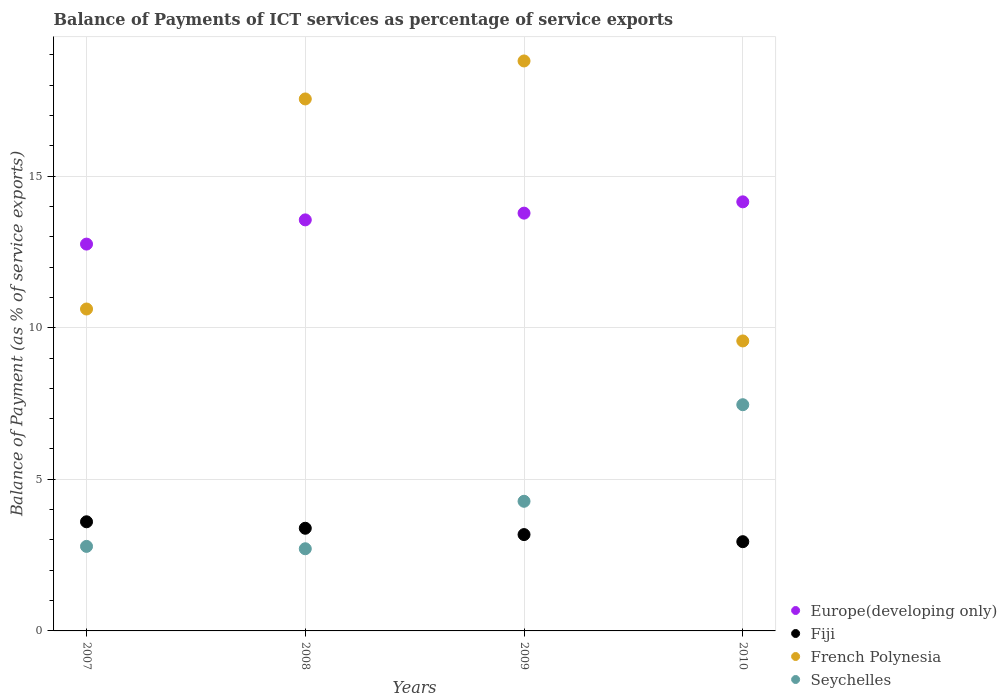What is the balance of payments of ICT services in Europe(developing only) in 2010?
Your answer should be very brief. 14.15. Across all years, what is the maximum balance of payments of ICT services in French Polynesia?
Your response must be concise. 18.8. Across all years, what is the minimum balance of payments of ICT services in French Polynesia?
Make the answer very short. 9.56. In which year was the balance of payments of ICT services in Europe(developing only) maximum?
Ensure brevity in your answer.  2010. In which year was the balance of payments of ICT services in French Polynesia minimum?
Provide a short and direct response. 2010. What is the total balance of payments of ICT services in French Polynesia in the graph?
Offer a very short reply. 56.52. What is the difference between the balance of payments of ICT services in French Polynesia in 2008 and that in 2010?
Provide a short and direct response. 7.98. What is the difference between the balance of payments of ICT services in Europe(developing only) in 2010 and the balance of payments of ICT services in Fiji in 2007?
Your answer should be very brief. 10.55. What is the average balance of payments of ICT services in Europe(developing only) per year?
Your response must be concise. 13.56. In the year 2009, what is the difference between the balance of payments of ICT services in Seychelles and balance of payments of ICT services in Fiji?
Keep it short and to the point. 1.1. What is the ratio of the balance of payments of ICT services in Seychelles in 2007 to that in 2010?
Give a very brief answer. 0.37. Is the difference between the balance of payments of ICT services in Seychelles in 2008 and 2009 greater than the difference between the balance of payments of ICT services in Fiji in 2008 and 2009?
Ensure brevity in your answer.  No. What is the difference between the highest and the second highest balance of payments of ICT services in Seychelles?
Provide a short and direct response. 3.18. What is the difference between the highest and the lowest balance of payments of ICT services in Seychelles?
Make the answer very short. 4.75. Is it the case that in every year, the sum of the balance of payments of ICT services in French Polynesia and balance of payments of ICT services in Europe(developing only)  is greater than the sum of balance of payments of ICT services in Seychelles and balance of payments of ICT services in Fiji?
Offer a very short reply. Yes. Is the balance of payments of ICT services in Seychelles strictly greater than the balance of payments of ICT services in Fiji over the years?
Your response must be concise. No. How many years are there in the graph?
Provide a short and direct response. 4. Are the values on the major ticks of Y-axis written in scientific E-notation?
Give a very brief answer. No. Does the graph contain grids?
Keep it short and to the point. Yes. Where does the legend appear in the graph?
Offer a very short reply. Bottom right. How are the legend labels stacked?
Ensure brevity in your answer.  Vertical. What is the title of the graph?
Give a very brief answer. Balance of Payments of ICT services as percentage of service exports. What is the label or title of the Y-axis?
Provide a short and direct response. Balance of Payment (as % of service exports). What is the Balance of Payment (as % of service exports) of Europe(developing only) in 2007?
Give a very brief answer. 12.76. What is the Balance of Payment (as % of service exports) in Fiji in 2007?
Your answer should be compact. 3.6. What is the Balance of Payment (as % of service exports) in French Polynesia in 2007?
Your answer should be compact. 10.62. What is the Balance of Payment (as % of service exports) of Seychelles in 2007?
Your answer should be compact. 2.79. What is the Balance of Payment (as % of service exports) of Europe(developing only) in 2008?
Your answer should be compact. 13.56. What is the Balance of Payment (as % of service exports) of Fiji in 2008?
Give a very brief answer. 3.39. What is the Balance of Payment (as % of service exports) of French Polynesia in 2008?
Make the answer very short. 17.54. What is the Balance of Payment (as % of service exports) of Seychelles in 2008?
Make the answer very short. 2.71. What is the Balance of Payment (as % of service exports) of Europe(developing only) in 2009?
Your answer should be very brief. 13.78. What is the Balance of Payment (as % of service exports) of Fiji in 2009?
Provide a succinct answer. 3.18. What is the Balance of Payment (as % of service exports) in French Polynesia in 2009?
Make the answer very short. 18.8. What is the Balance of Payment (as % of service exports) of Seychelles in 2009?
Offer a terse response. 4.28. What is the Balance of Payment (as % of service exports) of Europe(developing only) in 2010?
Your answer should be very brief. 14.15. What is the Balance of Payment (as % of service exports) in Fiji in 2010?
Make the answer very short. 2.94. What is the Balance of Payment (as % of service exports) in French Polynesia in 2010?
Keep it short and to the point. 9.56. What is the Balance of Payment (as % of service exports) of Seychelles in 2010?
Offer a terse response. 7.46. Across all years, what is the maximum Balance of Payment (as % of service exports) of Europe(developing only)?
Offer a very short reply. 14.15. Across all years, what is the maximum Balance of Payment (as % of service exports) of Fiji?
Your response must be concise. 3.6. Across all years, what is the maximum Balance of Payment (as % of service exports) in French Polynesia?
Make the answer very short. 18.8. Across all years, what is the maximum Balance of Payment (as % of service exports) of Seychelles?
Your response must be concise. 7.46. Across all years, what is the minimum Balance of Payment (as % of service exports) of Europe(developing only)?
Offer a terse response. 12.76. Across all years, what is the minimum Balance of Payment (as % of service exports) of Fiji?
Your answer should be very brief. 2.94. Across all years, what is the minimum Balance of Payment (as % of service exports) of French Polynesia?
Your answer should be very brief. 9.56. Across all years, what is the minimum Balance of Payment (as % of service exports) of Seychelles?
Keep it short and to the point. 2.71. What is the total Balance of Payment (as % of service exports) of Europe(developing only) in the graph?
Keep it short and to the point. 54.24. What is the total Balance of Payment (as % of service exports) in Fiji in the graph?
Offer a terse response. 13.1. What is the total Balance of Payment (as % of service exports) of French Polynesia in the graph?
Make the answer very short. 56.52. What is the total Balance of Payment (as % of service exports) in Seychelles in the graph?
Your response must be concise. 17.23. What is the difference between the Balance of Payment (as % of service exports) of Europe(developing only) in 2007 and that in 2008?
Keep it short and to the point. -0.8. What is the difference between the Balance of Payment (as % of service exports) in Fiji in 2007 and that in 2008?
Give a very brief answer. 0.21. What is the difference between the Balance of Payment (as % of service exports) in French Polynesia in 2007 and that in 2008?
Provide a short and direct response. -6.93. What is the difference between the Balance of Payment (as % of service exports) in Seychelles in 2007 and that in 2008?
Provide a short and direct response. 0.08. What is the difference between the Balance of Payment (as % of service exports) in Europe(developing only) in 2007 and that in 2009?
Your answer should be compact. -1.02. What is the difference between the Balance of Payment (as % of service exports) in Fiji in 2007 and that in 2009?
Offer a very short reply. 0.42. What is the difference between the Balance of Payment (as % of service exports) of French Polynesia in 2007 and that in 2009?
Your response must be concise. -8.18. What is the difference between the Balance of Payment (as % of service exports) in Seychelles in 2007 and that in 2009?
Your answer should be very brief. -1.49. What is the difference between the Balance of Payment (as % of service exports) in Europe(developing only) in 2007 and that in 2010?
Keep it short and to the point. -1.39. What is the difference between the Balance of Payment (as % of service exports) in Fiji in 2007 and that in 2010?
Keep it short and to the point. 0.66. What is the difference between the Balance of Payment (as % of service exports) of French Polynesia in 2007 and that in 2010?
Provide a short and direct response. 1.05. What is the difference between the Balance of Payment (as % of service exports) in Seychelles in 2007 and that in 2010?
Ensure brevity in your answer.  -4.67. What is the difference between the Balance of Payment (as % of service exports) in Europe(developing only) in 2008 and that in 2009?
Ensure brevity in your answer.  -0.22. What is the difference between the Balance of Payment (as % of service exports) in Fiji in 2008 and that in 2009?
Make the answer very short. 0.21. What is the difference between the Balance of Payment (as % of service exports) of French Polynesia in 2008 and that in 2009?
Provide a succinct answer. -1.25. What is the difference between the Balance of Payment (as % of service exports) of Seychelles in 2008 and that in 2009?
Your response must be concise. -1.57. What is the difference between the Balance of Payment (as % of service exports) in Europe(developing only) in 2008 and that in 2010?
Your response must be concise. -0.59. What is the difference between the Balance of Payment (as % of service exports) in Fiji in 2008 and that in 2010?
Give a very brief answer. 0.44. What is the difference between the Balance of Payment (as % of service exports) in French Polynesia in 2008 and that in 2010?
Make the answer very short. 7.98. What is the difference between the Balance of Payment (as % of service exports) in Seychelles in 2008 and that in 2010?
Provide a succinct answer. -4.75. What is the difference between the Balance of Payment (as % of service exports) of Europe(developing only) in 2009 and that in 2010?
Make the answer very short. -0.37. What is the difference between the Balance of Payment (as % of service exports) in Fiji in 2009 and that in 2010?
Provide a short and direct response. 0.23. What is the difference between the Balance of Payment (as % of service exports) of French Polynesia in 2009 and that in 2010?
Offer a terse response. 9.23. What is the difference between the Balance of Payment (as % of service exports) of Seychelles in 2009 and that in 2010?
Give a very brief answer. -3.18. What is the difference between the Balance of Payment (as % of service exports) of Europe(developing only) in 2007 and the Balance of Payment (as % of service exports) of Fiji in 2008?
Provide a succinct answer. 9.37. What is the difference between the Balance of Payment (as % of service exports) in Europe(developing only) in 2007 and the Balance of Payment (as % of service exports) in French Polynesia in 2008?
Keep it short and to the point. -4.79. What is the difference between the Balance of Payment (as % of service exports) of Europe(developing only) in 2007 and the Balance of Payment (as % of service exports) of Seychelles in 2008?
Give a very brief answer. 10.05. What is the difference between the Balance of Payment (as % of service exports) of Fiji in 2007 and the Balance of Payment (as % of service exports) of French Polynesia in 2008?
Provide a succinct answer. -13.94. What is the difference between the Balance of Payment (as % of service exports) of Fiji in 2007 and the Balance of Payment (as % of service exports) of Seychelles in 2008?
Your answer should be very brief. 0.89. What is the difference between the Balance of Payment (as % of service exports) in French Polynesia in 2007 and the Balance of Payment (as % of service exports) in Seychelles in 2008?
Your answer should be very brief. 7.91. What is the difference between the Balance of Payment (as % of service exports) in Europe(developing only) in 2007 and the Balance of Payment (as % of service exports) in Fiji in 2009?
Your response must be concise. 9.58. What is the difference between the Balance of Payment (as % of service exports) of Europe(developing only) in 2007 and the Balance of Payment (as % of service exports) of French Polynesia in 2009?
Give a very brief answer. -6.04. What is the difference between the Balance of Payment (as % of service exports) of Europe(developing only) in 2007 and the Balance of Payment (as % of service exports) of Seychelles in 2009?
Provide a succinct answer. 8.48. What is the difference between the Balance of Payment (as % of service exports) of Fiji in 2007 and the Balance of Payment (as % of service exports) of French Polynesia in 2009?
Give a very brief answer. -15.2. What is the difference between the Balance of Payment (as % of service exports) of Fiji in 2007 and the Balance of Payment (as % of service exports) of Seychelles in 2009?
Keep it short and to the point. -0.68. What is the difference between the Balance of Payment (as % of service exports) of French Polynesia in 2007 and the Balance of Payment (as % of service exports) of Seychelles in 2009?
Offer a very short reply. 6.34. What is the difference between the Balance of Payment (as % of service exports) of Europe(developing only) in 2007 and the Balance of Payment (as % of service exports) of Fiji in 2010?
Make the answer very short. 9.81. What is the difference between the Balance of Payment (as % of service exports) of Europe(developing only) in 2007 and the Balance of Payment (as % of service exports) of French Polynesia in 2010?
Ensure brevity in your answer.  3.19. What is the difference between the Balance of Payment (as % of service exports) in Europe(developing only) in 2007 and the Balance of Payment (as % of service exports) in Seychelles in 2010?
Keep it short and to the point. 5.3. What is the difference between the Balance of Payment (as % of service exports) of Fiji in 2007 and the Balance of Payment (as % of service exports) of French Polynesia in 2010?
Provide a succinct answer. -5.96. What is the difference between the Balance of Payment (as % of service exports) of Fiji in 2007 and the Balance of Payment (as % of service exports) of Seychelles in 2010?
Provide a short and direct response. -3.86. What is the difference between the Balance of Payment (as % of service exports) in French Polynesia in 2007 and the Balance of Payment (as % of service exports) in Seychelles in 2010?
Provide a succinct answer. 3.16. What is the difference between the Balance of Payment (as % of service exports) in Europe(developing only) in 2008 and the Balance of Payment (as % of service exports) in Fiji in 2009?
Ensure brevity in your answer.  10.38. What is the difference between the Balance of Payment (as % of service exports) in Europe(developing only) in 2008 and the Balance of Payment (as % of service exports) in French Polynesia in 2009?
Ensure brevity in your answer.  -5.24. What is the difference between the Balance of Payment (as % of service exports) in Europe(developing only) in 2008 and the Balance of Payment (as % of service exports) in Seychelles in 2009?
Ensure brevity in your answer.  9.28. What is the difference between the Balance of Payment (as % of service exports) in Fiji in 2008 and the Balance of Payment (as % of service exports) in French Polynesia in 2009?
Offer a terse response. -15.41. What is the difference between the Balance of Payment (as % of service exports) in Fiji in 2008 and the Balance of Payment (as % of service exports) in Seychelles in 2009?
Make the answer very short. -0.89. What is the difference between the Balance of Payment (as % of service exports) of French Polynesia in 2008 and the Balance of Payment (as % of service exports) of Seychelles in 2009?
Offer a very short reply. 13.27. What is the difference between the Balance of Payment (as % of service exports) of Europe(developing only) in 2008 and the Balance of Payment (as % of service exports) of Fiji in 2010?
Offer a terse response. 10.61. What is the difference between the Balance of Payment (as % of service exports) of Europe(developing only) in 2008 and the Balance of Payment (as % of service exports) of French Polynesia in 2010?
Ensure brevity in your answer.  3.99. What is the difference between the Balance of Payment (as % of service exports) in Europe(developing only) in 2008 and the Balance of Payment (as % of service exports) in Seychelles in 2010?
Keep it short and to the point. 6.1. What is the difference between the Balance of Payment (as % of service exports) of Fiji in 2008 and the Balance of Payment (as % of service exports) of French Polynesia in 2010?
Provide a short and direct response. -6.18. What is the difference between the Balance of Payment (as % of service exports) in Fiji in 2008 and the Balance of Payment (as % of service exports) in Seychelles in 2010?
Provide a short and direct response. -4.07. What is the difference between the Balance of Payment (as % of service exports) in French Polynesia in 2008 and the Balance of Payment (as % of service exports) in Seychelles in 2010?
Your answer should be compact. 10.08. What is the difference between the Balance of Payment (as % of service exports) in Europe(developing only) in 2009 and the Balance of Payment (as % of service exports) in Fiji in 2010?
Offer a very short reply. 10.83. What is the difference between the Balance of Payment (as % of service exports) in Europe(developing only) in 2009 and the Balance of Payment (as % of service exports) in French Polynesia in 2010?
Provide a short and direct response. 4.21. What is the difference between the Balance of Payment (as % of service exports) in Europe(developing only) in 2009 and the Balance of Payment (as % of service exports) in Seychelles in 2010?
Keep it short and to the point. 6.32. What is the difference between the Balance of Payment (as % of service exports) in Fiji in 2009 and the Balance of Payment (as % of service exports) in French Polynesia in 2010?
Keep it short and to the point. -6.39. What is the difference between the Balance of Payment (as % of service exports) in Fiji in 2009 and the Balance of Payment (as % of service exports) in Seychelles in 2010?
Give a very brief answer. -4.28. What is the difference between the Balance of Payment (as % of service exports) of French Polynesia in 2009 and the Balance of Payment (as % of service exports) of Seychelles in 2010?
Make the answer very short. 11.34. What is the average Balance of Payment (as % of service exports) in Europe(developing only) per year?
Keep it short and to the point. 13.56. What is the average Balance of Payment (as % of service exports) of Fiji per year?
Your response must be concise. 3.28. What is the average Balance of Payment (as % of service exports) of French Polynesia per year?
Ensure brevity in your answer.  14.13. What is the average Balance of Payment (as % of service exports) in Seychelles per year?
Make the answer very short. 4.31. In the year 2007, what is the difference between the Balance of Payment (as % of service exports) in Europe(developing only) and Balance of Payment (as % of service exports) in Fiji?
Ensure brevity in your answer.  9.16. In the year 2007, what is the difference between the Balance of Payment (as % of service exports) of Europe(developing only) and Balance of Payment (as % of service exports) of French Polynesia?
Offer a terse response. 2.14. In the year 2007, what is the difference between the Balance of Payment (as % of service exports) in Europe(developing only) and Balance of Payment (as % of service exports) in Seychelles?
Provide a short and direct response. 9.97. In the year 2007, what is the difference between the Balance of Payment (as % of service exports) of Fiji and Balance of Payment (as % of service exports) of French Polynesia?
Provide a succinct answer. -7.02. In the year 2007, what is the difference between the Balance of Payment (as % of service exports) in Fiji and Balance of Payment (as % of service exports) in Seychelles?
Offer a terse response. 0.81. In the year 2007, what is the difference between the Balance of Payment (as % of service exports) of French Polynesia and Balance of Payment (as % of service exports) of Seychelles?
Your answer should be compact. 7.83. In the year 2008, what is the difference between the Balance of Payment (as % of service exports) of Europe(developing only) and Balance of Payment (as % of service exports) of Fiji?
Provide a short and direct response. 10.17. In the year 2008, what is the difference between the Balance of Payment (as % of service exports) in Europe(developing only) and Balance of Payment (as % of service exports) in French Polynesia?
Your answer should be compact. -3.99. In the year 2008, what is the difference between the Balance of Payment (as % of service exports) in Europe(developing only) and Balance of Payment (as % of service exports) in Seychelles?
Offer a very short reply. 10.85. In the year 2008, what is the difference between the Balance of Payment (as % of service exports) in Fiji and Balance of Payment (as % of service exports) in French Polynesia?
Keep it short and to the point. -14.16. In the year 2008, what is the difference between the Balance of Payment (as % of service exports) in Fiji and Balance of Payment (as % of service exports) in Seychelles?
Ensure brevity in your answer.  0.68. In the year 2008, what is the difference between the Balance of Payment (as % of service exports) in French Polynesia and Balance of Payment (as % of service exports) in Seychelles?
Your answer should be very brief. 14.83. In the year 2009, what is the difference between the Balance of Payment (as % of service exports) of Europe(developing only) and Balance of Payment (as % of service exports) of Fiji?
Your answer should be very brief. 10.6. In the year 2009, what is the difference between the Balance of Payment (as % of service exports) in Europe(developing only) and Balance of Payment (as % of service exports) in French Polynesia?
Your answer should be very brief. -5.02. In the year 2009, what is the difference between the Balance of Payment (as % of service exports) of Europe(developing only) and Balance of Payment (as % of service exports) of Seychelles?
Ensure brevity in your answer.  9.5. In the year 2009, what is the difference between the Balance of Payment (as % of service exports) in Fiji and Balance of Payment (as % of service exports) in French Polynesia?
Offer a very short reply. -15.62. In the year 2009, what is the difference between the Balance of Payment (as % of service exports) in Fiji and Balance of Payment (as % of service exports) in Seychelles?
Keep it short and to the point. -1.1. In the year 2009, what is the difference between the Balance of Payment (as % of service exports) of French Polynesia and Balance of Payment (as % of service exports) of Seychelles?
Provide a succinct answer. 14.52. In the year 2010, what is the difference between the Balance of Payment (as % of service exports) of Europe(developing only) and Balance of Payment (as % of service exports) of Fiji?
Provide a short and direct response. 11.21. In the year 2010, what is the difference between the Balance of Payment (as % of service exports) in Europe(developing only) and Balance of Payment (as % of service exports) in French Polynesia?
Make the answer very short. 4.59. In the year 2010, what is the difference between the Balance of Payment (as % of service exports) in Europe(developing only) and Balance of Payment (as % of service exports) in Seychelles?
Offer a very short reply. 6.69. In the year 2010, what is the difference between the Balance of Payment (as % of service exports) of Fiji and Balance of Payment (as % of service exports) of French Polynesia?
Your answer should be compact. -6.62. In the year 2010, what is the difference between the Balance of Payment (as % of service exports) in Fiji and Balance of Payment (as % of service exports) in Seychelles?
Offer a terse response. -4.52. In the year 2010, what is the difference between the Balance of Payment (as % of service exports) in French Polynesia and Balance of Payment (as % of service exports) in Seychelles?
Your answer should be compact. 2.1. What is the ratio of the Balance of Payment (as % of service exports) of Europe(developing only) in 2007 to that in 2008?
Ensure brevity in your answer.  0.94. What is the ratio of the Balance of Payment (as % of service exports) in Fiji in 2007 to that in 2008?
Offer a very short reply. 1.06. What is the ratio of the Balance of Payment (as % of service exports) of French Polynesia in 2007 to that in 2008?
Your answer should be very brief. 0.61. What is the ratio of the Balance of Payment (as % of service exports) in Seychelles in 2007 to that in 2008?
Keep it short and to the point. 1.03. What is the ratio of the Balance of Payment (as % of service exports) in Europe(developing only) in 2007 to that in 2009?
Give a very brief answer. 0.93. What is the ratio of the Balance of Payment (as % of service exports) of Fiji in 2007 to that in 2009?
Keep it short and to the point. 1.13. What is the ratio of the Balance of Payment (as % of service exports) of French Polynesia in 2007 to that in 2009?
Your answer should be compact. 0.56. What is the ratio of the Balance of Payment (as % of service exports) of Seychelles in 2007 to that in 2009?
Your response must be concise. 0.65. What is the ratio of the Balance of Payment (as % of service exports) of Europe(developing only) in 2007 to that in 2010?
Give a very brief answer. 0.9. What is the ratio of the Balance of Payment (as % of service exports) in Fiji in 2007 to that in 2010?
Offer a very short reply. 1.22. What is the ratio of the Balance of Payment (as % of service exports) of French Polynesia in 2007 to that in 2010?
Offer a very short reply. 1.11. What is the ratio of the Balance of Payment (as % of service exports) of Seychelles in 2007 to that in 2010?
Provide a succinct answer. 0.37. What is the ratio of the Balance of Payment (as % of service exports) of Europe(developing only) in 2008 to that in 2009?
Make the answer very short. 0.98. What is the ratio of the Balance of Payment (as % of service exports) in Fiji in 2008 to that in 2009?
Give a very brief answer. 1.07. What is the ratio of the Balance of Payment (as % of service exports) of French Polynesia in 2008 to that in 2009?
Your answer should be compact. 0.93. What is the ratio of the Balance of Payment (as % of service exports) of Seychelles in 2008 to that in 2009?
Make the answer very short. 0.63. What is the ratio of the Balance of Payment (as % of service exports) of Europe(developing only) in 2008 to that in 2010?
Your response must be concise. 0.96. What is the ratio of the Balance of Payment (as % of service exports) of Fiji in 2008 to that in 2010?
Your response must be concise. 1.15. What is the ratio of the Balance of Payment (as % of service exports) in French Polynesia in 2008 to that in 2010?
Provide a short and direct response. 1.83. What is the ratio of the Balance of Payment (as % of service exports) of Seychelles in 2008 to that in 2010?
Keep it short and to the point. 0.36. What is the ratio of the Balance of Payment (as % of service exports) in Europe(developing only) in 2009 to that in 2010?
Your answer should be compact. 0.97. What is the ratio of the Balance of Payment (as % of service exports) in Fiji in 2009 to that in 2010?
Make the answer very short. 1.08. What is the ratio of the Balance of Payment (as % of service exports) of French Polynesia in 2009 to that in 2010?
Ensure brevity in your answer.  1.97. What is the ratio of the Balance of Payment (as % of service exports) in Seychelles in 2009 to that in 2010?
Make the answer very short. 0.57. What is the difference between the highest and the second highest Balance of Payment (as % of service exports) in Europe(developing only)?
Your answer should be very brief. 0.37. What is the difference between the highest and the second highest Balance of Payment (as % of service exports) of Fiji?
Provide a short and direct response. 0.21. What is the difference between the highest and the second highest Balance of Payment (as % of service exports) in French Polynesia?
Your response must be concise. 1.25. What is the difference between the highest and the second highest Balance of Payment (as % of service exports) in Seychelles?
Offer a very short reply. 3.18. What is the difference between the highest and the lowest Balance of Payment (as % of service exports) of Europe(developing only)?
Provide a succinct answer. 1.39. What is the difference between the highest and the lowest Balance of Payment (as % of service exports) of Fiji?
Provide a succinct answer. 0.66. What is the difference between the highest and the lowest Balance of Payment (as % of service exports) in French Polynesia?
Your response must be concise. 9.23. What is the difference between the highest and the lowest Balance of Payment (as % of service exports) of Seychelles?
Offer a very short reply. 4.75. 